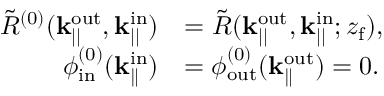Convert formula to latex. <formula><loc_0><loc_0><loc_500><loc_500>\begin{array} { r l } { \tilde { R } ^ { ( 0 ) } ( k _ { | | } ^ { o u t } , k _ { | | } ^ { i n } ) } & { = \tilde { R } ( k _ { | | } ^ { o u t } , k _ { | | } ^ { i n } ; z _ { f } ) , } \\ { \phi _ { i n } ^ { ( 0 ) } ( k _ { \| } ^ { i n } ) } & { = \phi _ { o u t } ^ { ( 0 ) } ( k _ { \| } ^ { o u t } ) = 0 . } \end{array}</formula> 